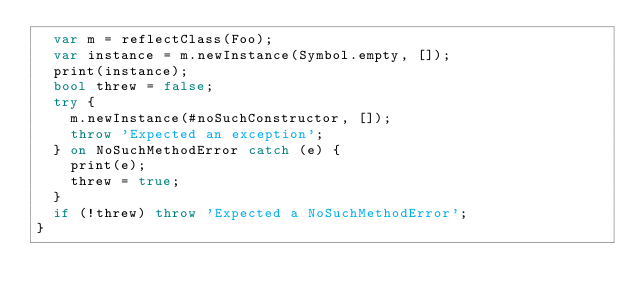<code> <loc_0><loc_0><loc_500><loc_500><_Dart_>  var m = reflectClass(Foo);
  var instance = m.newInstance(Symbol.empty, []);
  print(instance);
  bool threw = false;
  try {
    m.newInstance(#noSuchConstructor, []);
    throw 'Expected an exception';
  } on NoSuchMethodError catch (e) {
    print(e);
    threw = true;
  }
  if (!threw) throw 'Expected a NoSuchMethodError';
}
</code> 